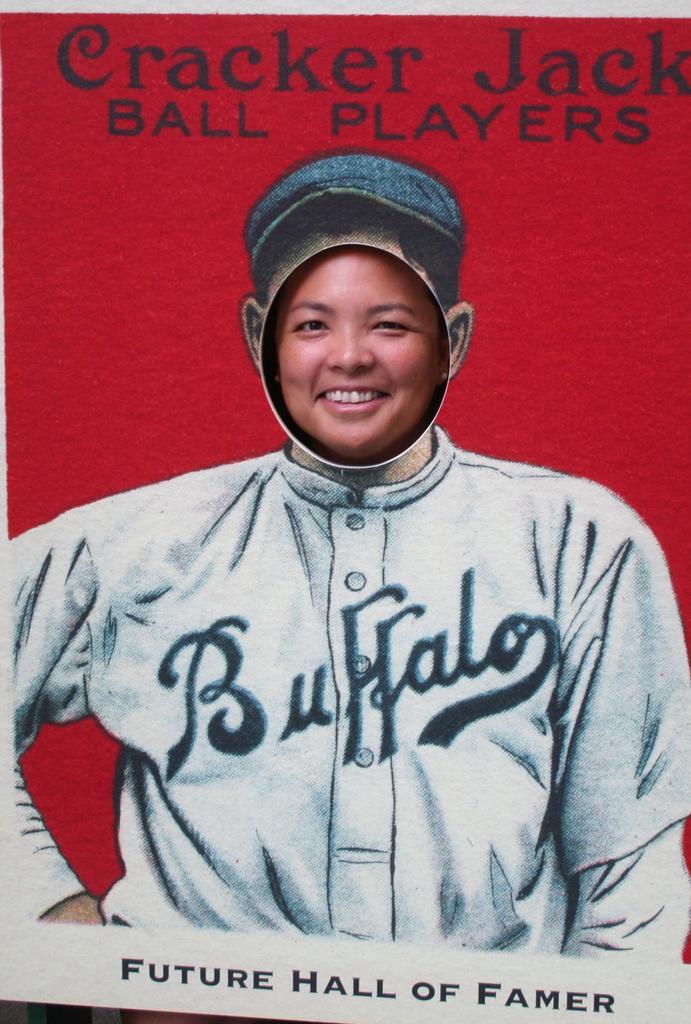How would you summarize this image in a sentence or two? This is a poster and in this poster we can see a person smiling and some text. 